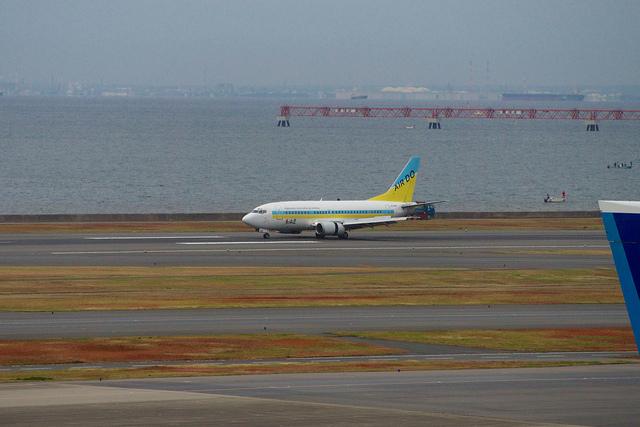Is there a large body of water?
Give a very brief answer. Yes. Did this plan land on an aircraft carrier?
Write a very short answer. No. How many planes are there?
Quick response, please. 1. What is the name of the aircraft's manufacturer?
Write a very short answer. Arbo. How many engines are visible?
Answer briefly. 1. Is this a commercial aircraft?
Write a very short answer. Yes. 